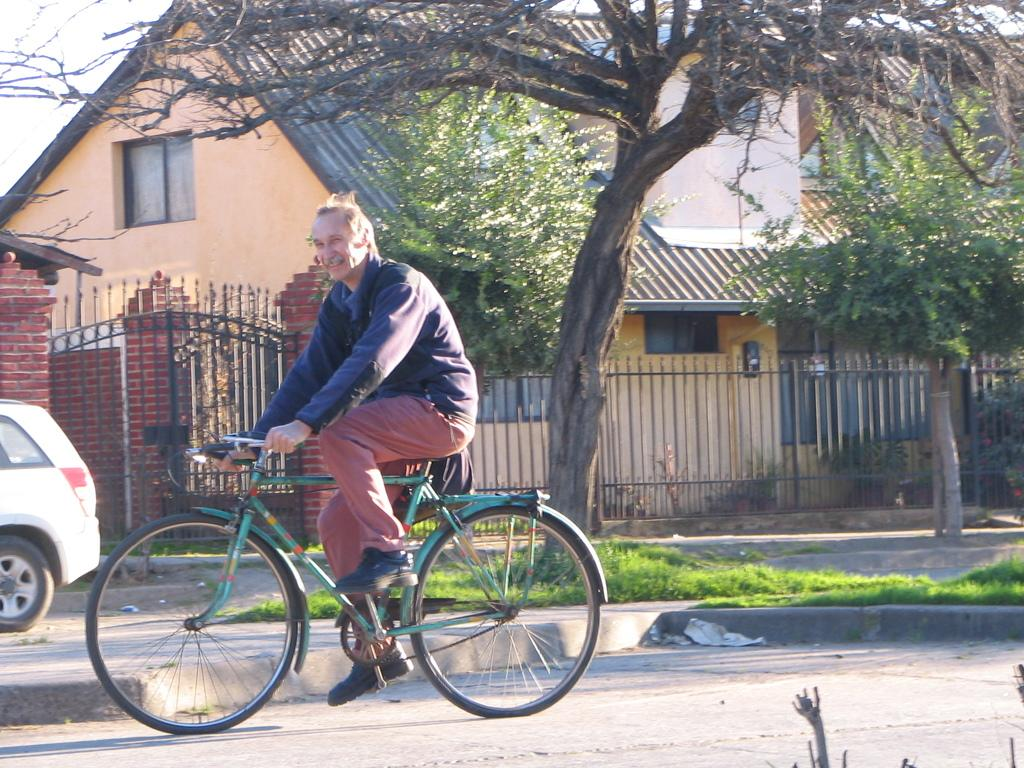What is the person in the image doing? The person in the image is riding a bicycle. What else can be seen on the road in the image? There is a car on the road in the image. What can be seen in the background of the image? There is a railing, trees, a building, and the sky visible in the background of the image. What type of quilt is being used to push the bicycle in the image? There is no quilt or pushing action involving a quilt present in the image. 